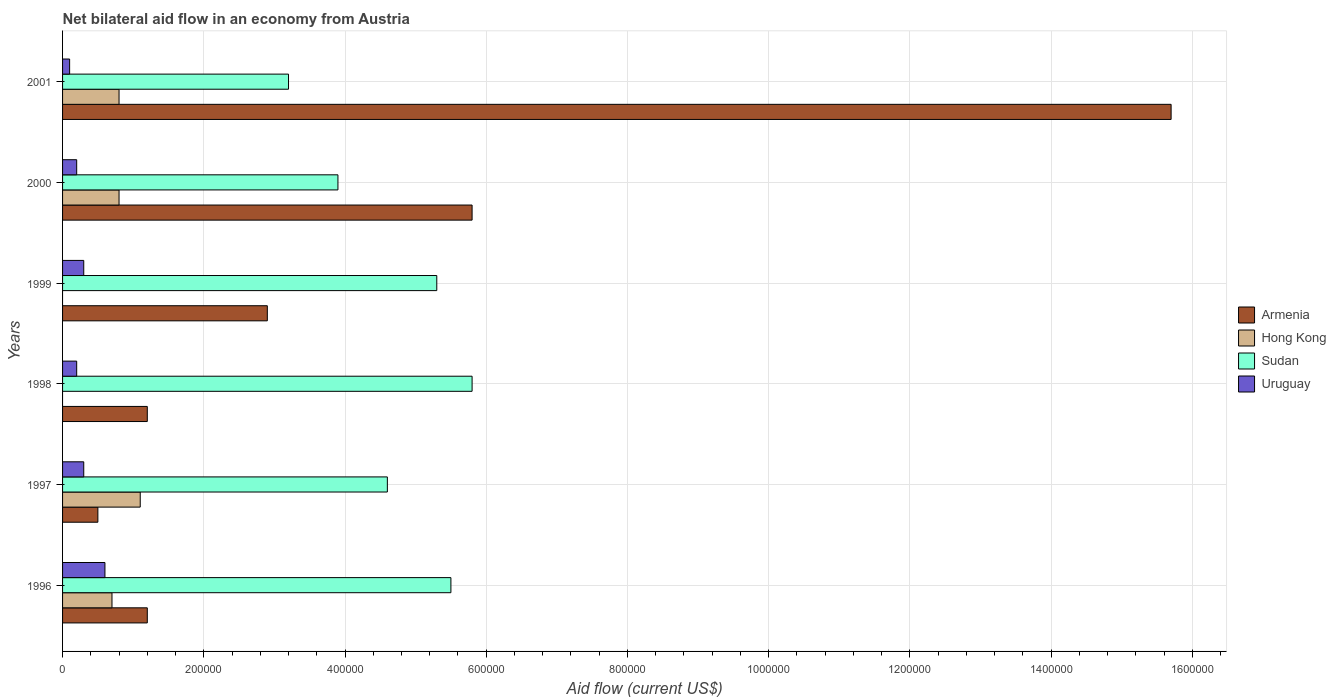How many different coloured bars are there?
Keep it short and to the point. 4. How many groups of bars are there?
Provide a succinct answer. 6. What is the net bilateral aid flow in Hong Kong in 1997?
Provide a short and direct response. 1.10e+05. Across all years, what is the maximum net bilateral aid flow in Sudan?
Provide a succinct answer. 5.80e+05. What is the total net bilateral aid flow in Armenia in the graph?
Give a very brief answer. 2.73e+06. What is the difference between the net bilateral aid flow in Hong Kong in 2001 and the net bilateral aid flow in Armenia in 1999?
Provide a succinct answer. -2.10e+05. What is the average net bilateral aid flow in Sudan per year?
Provide a short and direct response. 4.72e+05. In how many years, is the net bilateral aid flow in Sudan greater than 920000 US$?
Make the answer very short. 0. What is the ratio of the net bilateral aid flow in Sudan in 1999 to that in 2001?
Provide a succinct answer. 1.66. Is the difference between the net bilateral aid flow in Sudan in 1999 and 2001 greater than the difference between the net bilateral aid flow in Uruguay in 1999 and 2001?
Give a very brief answer. Yes. What is the difference between the highest and the lowest net bilateral aid flow in Armenia?
Your answer should be compact. 1.52e+06. In how many years, is the net bilateral aid flow in Sudan greater than the average net bilateral aid flow in Sudan taken over all years?
Give a very brief answer. 3. Is the sum of the net bilateral aid flow in Uruguay in 1996 and 1998 greater than the maximum net bilateral aid flow in Sudan across all years?
Offer a terse response. No. How many bars are there?
Provide a succinct answer. 22. Are all the bars in the graph horizontal?
Offer a very short reply. Yes. How many years are there in the graph?
Offer a very short reply. 6. What is the difference between two consecutive major ticks on the X-axis?
Offer a terse response. 2.00e+05. Are the values on the major ticks of X-axis written in scientific E-notation?
Provide a short and direct response. No. Does the graph contain any zero values?
Offer a terse response. Yes. How many legend labels are there?
Give a very brief answer. 4. What is the title of the graph?
Give a very brief answer. Net bilateral aid flow in an economy from Austria. Does "Brazil" appear as one of the legend labels in the graph?
Keep it short and to the point. No. What is the Aid flow (current US$) in Sudan in 1996?
Offer a terse response. 5.50e+05. What is the Aid flow (current US$) of Armenia in 1997?
Your response must be concise. 5.00e+04. What is the Aid flow (current US$) in Sudan in 1998?
Give a very brief answer. 5.80e+05. What is the Aid flow (current US$) in Sudan in 1999?
Give a very brief answer. 5.30e+05. What is the Aid flow (current US$) of Uruguay in 1999?
Ensure brevity in your answer.  3.00e+04. What is the Aid flow (current US$) of Armenia in 2000?
Offer a terse response. 5.80e+05. What is the Aid flow (current US$) of Armenia in 2001?
Provide a short and direct response. 1.57e+06. Across all years, what is the maximum Aid flow (current US$) of Armenia?
Your response must be concise. 1.57e+06. Across all years, what is the maximum Aid flow (current US$) in Hong Kong?
Provide a short and direct response. 1.10e+05. Across all years, what is the maximum Aid flow (current US$) of Sudan?
Make the answer very short. 5.80e+05. Across all years, what is the maximum Aid flow (current US$) in Uruguay?
Provide a succinct answer. 6.00e+04. Across all years, what is the minimum Aid flow (current US$) in Sudan?
Your response must be concise. 3.20e+05. What is the total Aid flow (current US$) of Armenia in the graph?
Give a very brief answer. 2.73e+06. What is the total Aid flow (current US$) of Sudan in the graph?
Give a very brief answer. 2.83e+06. What is the difference between the Aid flow (current US$) of Hong Kong in 1996 and that in 1997?
Provide a succinct answer. -4.00e+04. What is the difference between the Aid flow (current US$) in Uruguay in 1996 and that in 1998?
Your answer should be very brief. 4.00e+04. What is the difference between the Aid flow (current US$) in Armenia in 1996 and that in 1999?
Offer a terse response. -1.70e+05. What is the difference between the Aid flow (current US$) in Armenia in 1996 and that in 2000?
Provide a succinct answer. -4.60e+05. What is the difference between the Aid flow (current US$) in Uruguay in 1996 and that in 2000?
Provide a short and direct response. 4.00e+04. What is the difference between the Aid flow (current US$) of Armenia in 1996 and that in 2001?
Offer a very short reply. -1.45e+06. What is the difference between the Aid flow (current US$) of Sudan in 1996 and that in 2001?
Your response must be concise. 2.30e+05. What is the difference between the Aid flow (current US$) of Uruguay in 1996 and that in 2001?
Your response must be concise. 5.00e+04. What is the difference between the Aid flow (current US$) in Armenia in 1997 and that in 1998?
Offer a very short reply. -7.00e+04. What is the difference between the Aid flow (current US$) in Sudan in 1997 and that in 1998?
Provide a succinct answer. -1.20e+05. What is the difference between the Aid flow (current US$) in Sudan in 1997 and that in 1999?
Your response must be concise. -7.00e+04. What is the difference between the Aid flow (current US$) of Uruguay in 1997 and that in 1999?
Provide a short and direct response. 0. What is the difference between the Aid flow (current US$) in Armenia in 1997 and that in 2000?
Your answer should be very brief. -5.30e+05. What is the difference between the Aid flow (current US$) of Uruguay in 1997 and that in 2000?
Offer a terse response. 10000. What is the difference between the Aid flow (current US$) in Armenia in 1997 and that in 2001?
Give a very brief answer. -1.52e+06. What is the difference between the Aid flow (current US$) of Hong Kong in 1997 and that in 2001?
Your response must be concise. 3.00e+04. What is the difference between the Aid flow (current US$) in Armenia in 1998 and that in 1999?
Your response must be concise. -1.70e+05. What is the difference between the Aid flow (current US$) in Uruguay in 1998 and that in 1999?
Your response must be concise. -10000. What is the difference between the Aid flow (current US$) of Armenia in 1998 and that in 2000?
Offer a terse response. -4.60e+05. What is the difference between the Aid flow (current US$) of Sudan in 1998 and that in 2000?
Offer a terse response. 1.90e+05. What is the difference between the Aid flow (current US$) in Armenia in 1998 and that in 2001?
Keep it short and to the point. -1.45e+06. What is the difference between the Aid flow (current US$) in Uruguay in 1998 and that in 2001?
Provide a succinct answer. 10000. What is the difference between the Aid flow (current US$) of Sudan in 1999 and that in 2000?
Provide a short and direct response. 1.40e+05. What is the difference between the Aid flow (current US$) in Armenia in 1999 and that in 2001?
Provide a short and direct response. -1.28e+06. What is the difference between the Aid flow (current US$) in Uruguay in 1999 and that in 2001?
Offer a terse response. 2.00e+04. What is the difference between the Aid flow (current US$) in Armenia in 2000 and that in 2001?
Your answer should be very brief. -9.90e+05. What is the difference between the Aid flow (current US$) in Hong Kong in 2000 and that in 2001?
Provide a short and direct response. 0. What is the difference between the Aid flow (current US$) in Sudan in 2000 and that in 2001?
Your response must be concise. 7.00e+04. What is the difference between the Aid flow (current US$) in Uruguay in 2000 and that in 2001?
Give a very brief answer. 10000. What is the difference between the Aid flow (current US$) of Armenia in 1996 and the Aid flow (current US$) of Hong Kong in 1997?
Keep it short and to the point. 10000. What is the difference between the Aid flow (current US$) in Hong Kong in 1996 and the Aid flow (current US$) in Sudan in 1997?
Your answer should be very brief. -3.90e+05. What is the difference between the Aid flow (current US$) of Sudan in 1996 and the Aid flow (current US$) of Uruguay in 1997?
Your answer should be compact. 5.20e+05. What is the difference between the Aid flow (current US$) in Armenia in 1996 and the Aid flow (current US$) in Sudan in 1998?
Your answer should be very brief. -4.60e+05. What is the difference between the Aid flow (current US$) in Hong Kong in 1996 and the Aid flow (current US$) in Sudan in 1998?
Make the answer very short. -5.10e+05. What is the difference between the Aid flow (current US$) in Sudan in 1996 and the Aid flow (current US$) in Uruguay in 1998?
Ensure brevity in your answer.  5.30e+05. What is the difference between the Aid flow (current US$) in Armenia in 1996 and the Aid flow (current US$) in Sudan in 1999?
Keep it short and to the point. -4.10e+05. What is the difference between the Aid flow (current US$) in Hong Kong in 1996 and the Aid flow (current US$) in Sudan in 1999?
Your response must be concise. -4.60e+05. What is the difference between the Aid flow (current US$) of Sudan in 1996 and the Aid flow (current US$) of Uruguay in 1999?
Give a very brief answer. 5.20e+05. What is the difference between the Aid flow (current US$) of Armenia in 1996 and the Aid flow (current US$) of Sudan in 2000?
Your answer should be compact. -2.70e+05. What is the difference between the Aid flow (current US$) of Hong Kong in 1996 and the Aid flow (current US$) of Sudan in 2000?
Make the answer very short. -3.20e+05. What is the difference between the Aid flow (current US$) of Sudan in 1996 and the Aid flow (current US$) of Uruguay in 2000?
Give a very brief answer. 5.30e+05. What is the difference between the Aid flow (current US$) of Armenia in 1996 and the Aid flow (current US$) of Hong Kong in 2001?
Give a very brief answer. 4.00e+04. What is the difference between the Aid flow (current US$) of Armenia in 1996 and the Aid flow (current US$) of Sudan in 2001?
Ensure brevity in your answer.  -2.00e+05. What is the difference between the Aid flow (current US$) in Armenia in 1996 and the Aid flow (current US$) in Uruguay in 2001?
Provide a short and direct response. 1.10e+05. What is the difference between the Aid flow (current US$) of Hong Kong in 1996 and the Aid flow (current US$) of Sudan in 2001?
Give a very brief answer. -2.50e+05. What is the difference between the Aid flow (current US$) of Sudan in 1996 and the Aid flow (current US$) of Uruguay in 2001?
Your response must be concise. 5.40e+05. What is the difference between the Aid flow (current US$) of Armenia in 1997 and the Aid flow (current US$) of Sudan in 1998?
Ensure brevity in your answer.  -5.30e+05. What is the difference between the Aid flow (current US$) in Hong Kong in 1997 and the Aid flow (current US$) in Sudan in 1998?
Your answer should be very brief. -4.70e+05. What is the difference between the Aid flow (current US$) in Hong Kong in 1997 and the Aid flow (current US$) in Uruguay in 1998?
Offer a terse response. 9.00e+04. What is the difference between the Aid flow (current US$) in Sudan in 1997 and the Aid flow (current US$) in Uruguay in 1998?
Provide a short and direct response. 4.40e+05. What is the difference between the Aid flow (current US$) of Armenia in 1997 and the Aid flow (current US$) of Sudan in 1999?
Keep it short and to the point. -4.80e+05. What is the difference between the Aid flow (current US$) in Armenia in 1997 and the Aid flow (current US$) in Uruguay in 1999?
Your response must be concise. 2.00e+04. What is the difference between the Aid flow (current US$) in Hong Kong in 1997 and the Aid flow (current US$) in Sudan in 1999?
Offer a terse response. -4.20e+05. What is the difference between the Aid flow (current US$) of Armenia in 1997 and the Aid flow (current US$) of Hong Kong in 2000?
Your answer should be compact. -3.00e+04. What is the difference between the Aid flow (current US$) of Hong Kong in 1997 and the Aid flow (current US$) of Sudan in 2000?
Keep it short and to the point. -2.80e+05. What is the difference between the Aid flow (current US$) of Hong Kong in 1997 and the Aid flow (current US$) of Uruguay in 2000?
Give a very brief answer. 9.00e+04. What is the difference between the Aid flow (current US$) of Sudan in 1997 and the Aid flow (current US$) of Uruguay in 2000?
Make the answer very short. 4.40e+05. What is the difference between the Aid flow (current US$) in Armenia in 1997 and the Aid flow (current US$) in Sudan in 2001?
Give a very brief answer. -2.70e+05. What is the difference between the Aid flow (current US$) of Armenia in 1997 and the Aid flow (current US$) of Uruguay in 2001?
Provide a short and direct response. 4.00e+04. What is the difference between the Aid flow (current US$) in Hong Kong in 1997 and the Aid flow (current US$) in Sudan in 2001?
Provide a succinct answer. -2.10e+05. What is the difference between the Aid flow (current US$) of Hong Kong in 1997 and the Aid flow (current US$) of Uruguay in 2001?
Keep it short and to the point. 1.00e+05. What is the difference between the Aid flow (current US$) in Sudan in 1997 and the Aid flow (current US$) in Uruguay in 2001?
Ensure brevity in your answer.  4.50e+05. What is the difference between the Aid flow (current US$) of Armenia in 1998 and the Aid flow (current US$) of Sudan in 1999?
Keep it short and to the point. -4.10e+05. What is the difference between the Aid flow (current US$) of Sudan in 1998 and the Aid flow (current US$) of Uruguay in 1999?
Make the answer very short. 5.50e+05. What is the difference between the Aid flow (current US$) in Armenia in 1998 and the Aid flow (current US$) in Hong Kong in 2000?
Provide a succinct answer. 4.00e+04. What is the difference between the Aid flow (current US$) of Armenia in 1998 and the Aid flow (current US$) of Uruguay in 2000?
Provide a short and direct response. 1.00e+05. What is the difference between the Aid flow (current US$) in Sudan in 1998 and the Aid flow (current US$) in Uruguay in 2000?
Offer a very short reply. 5.60e+05. What is the difference between the Aid flow (current US$) of Armenia in 1998 and the Aid flow (current US$) of Sudan in 2001?
Provide a short and direct response. -2.00e+05. What is the difference between the Aid flow (current US$) of Armenia in 1998 and the Aid flow (current US$) of Uruguay in 2001?
Your response must be concise. 1.10e+05. What is the difference between the Aid flow (current US$) of Sudan in 1998 and the Aid flow (current US$) of Uruguay in 2001?
Offer a very short reply. 5.70e+05. What is the difference between the Aid flow (current US$) of Armenia in 1999 and the Aid flow (current US$) of Hong Kong in 2000?
Provide a succinct answer. 2.10e+05. What is the difference between the Aid flow (current US$) of Sudan in 1999 and the Aid flow (current US$) of Uruguay in 2000?
Ensure brevity in your answer.  5.10e+05. What is the difference between the Aid flow (current US$) of Armenia in 1999 and the Aid flow (current US$) of Hong Kong in 2001?
Keep it short and to the point. 2.10e+05. What is the difference between the Aid flow (current US$) of Armenia in 1999 and the Aid flow (current US$) of Sudan in 2001?
Make the answer very short. -3.00e+04. What is the difference between the Aid flow (current US$) of Sudan in 1999 and the Aid flow (current US$) of Uruguay in 2001?
Your response must be concise. 5.20e+05. What is the difference between the Aid flow (current US$) in Armenia in 2000 and the Aid flow (current US$) in Uruguay in 2001?
Provide a short and direct response. 5.70e+05. What is the difference between the Aid flow (current US$) in Hong Kong in 2000 and the Aid flow (current US$) in Sudan in 2001?
Make the answer very short. -2.40e+05. What is the difference between the Aid flow (current US$) of Sudan in 2000 and the Aid flow (current US$) of Uruguay in 2001?
Provide a succinct answer. 3.80e+05. What is the average Aid flow (current US$) in Armenia per year?
Offer a very short reply. 4.55e+05. What is the average Aid flow (current US$) in Hong Kong per year?
Keep it short and to the point. 5.67e+04. What is the average Aid flow (current US$) in Sudan per year?
Keep it short and to the point. 4.72e+05. What is the average Aid flow (current US$) in Uruguay per year?
Your answer should be compact. 2.83e+04. In the year 1996, what is the difference between the Aid flow (current US$) of Armenia and Aid flow (current US$) of Hong Kong?
Your answer should be very brief. 5.00e+04. In the year 1996, what is the difference between the Aid flow (current US$) in Armenia and Aid flow (current US$) in Sudan?
Provide a succinct answer. -4.30e+05. In the year 1996, what is the difference between the Aid flow (current US$) of Armenia and Aid flow (current US$) of Uruguay?
Offer a terse response. 6.00e+04. In the year 1996, what is the difference between the Aid flow (current US$) in Hong Kong and Aid flow (current US$) in Sudan?
Ensure brevity in your answer.  -4.80e+05. In the year 1996, what is the difference between the Aid flow (current US$) in Hong Kong and Aid flow (current US$) in Uruguay?
Offer a terse response. 10000. In the year 1997, what is the difference between the Aid flow (current US$) of Armenia and Aid flow (current US$) of Sudan?
Make the answer very short. -4.10e+05. In the year 1997, what is the difference between the Aid flow (current US$) of Hong Kong and Aid flow (current US$) of Sudan?
Give a very brief answer. -3.50e+05. In the year 1998, what is the difference between the Aid flow (current US$) in Armenia and Aid flow (current US$) in Sudan?
Your answer should be very brief. -4.60e+05. In the year 1998, what is the difference between the Aid flow (current US$) in Armenia and Aid flow (current US$) in Uruguay?
Provide a succinct answer. 1.00e+05. In the year 1998, what is the difference between the Aid flow (current US$) of Sudan and Aid flow (current US$) of Uruguay?
Offer a terse response. 5.60e+05. In the year 1999, what is the difference between the Aid flow (current US$) of Armenia and Aid flow (current US$) of Uruguay?
Your answer should be very brief. 2.60e+05. In the year 2000, what is the difference between the Aid flow (current US$) of Armenia and Aid flow (current US$) of Hong Kong?
Your answer should be very brief. 5.00e+05. In the year 2000, what is the difference between the Aid flow (current US$) in Armenia and Aid flow (current US$) in Uruguay?
Give a very brief answer. 5.60e+05. In the year 2000, what is the difference between the Aid flow (current US$) of Hong Kong and Aid flow (current US$) of Sudan?
Give a very brief answer. -3.10e+05. In the year 2000, what is the difference between the Aid flow (current US$) of Hong Kong and Aid flow (current US$) of Uruguay?
Your answer should be very brief. 6.00e+04. In the year 2001, what is the difference between the Aid flow (current US$) of Armenia and Aid flow (current US$) of Hong Kong?
Keep it short and to the point. 1.49e+06. In the year 2001, what is the difference between the Aid flow (current US$) in Armenia and Aid flow (current US$) in Sudan?
Your answer should be very brief. 1.25e+06. In the year 2001, what is the difference between the Aid flow (current US$) of Armenia and Aid flow (current US$) of Uruguay?
Provide a succinct answer. 1.56e+06. In the year 2001, what is the difference between the Aid flow (current US$) of Sudan and Aid flow (current US$) of Uruguay?
Your answer should be very brief. 3.10e+05. What is the ratio of the Aid flow (current US$) of Armenia in 1996 to that in 1997?
Keep it short and to the point. 2.4. What is the ratio of the Aid flow (current US$) in Hong Kong in 1996 to that in 1997?
Keep it short and to the point. 0.64. What is the ratio of the Aid flow (current US$) of Sudan in 1996 to that in 1997?
Ensure brevity in your answer.  1.2. What is the ratio of the Aid flow (current US$) of Sudan in 1996 to that in 1998?
Give a very brief answer. 0.95. What is the ratio of the Aid flow (current US$) of Uruguay in 1996 to that in 1998?
Provide a short and direct response. 3. What is the ratio of the Aid flow (current US$) of Armenia in 1996 to that in 1999?
Provide a succinct answer. 0.41. What is the ratio of the Aid flow (current US$) of Sudan in 1996 to that in 1999?
Give a very brief answer. 1.04. What is the ratio of the Aid flow (current US$) in Uruguay in 1996 to that in 1999?
Provide a succinct answer. 2. What is the ratio of the Aid flow (current US$) in Armenia in 1996 to that in 2000?
Offer a very short reply. 0.21. What is the ratio of the Aid flow (current US$) of Sudan in 1996 to that in 2000?
Provide a short and direct response. 1.41. What is the ratio of the Aid flow (current US$) of Armenia in 1996 to that in 2001?
Offer a very short reply. 0.08. What is the ratio of the Aid flow (current US$) of Hong Kong in 1996 to that in 2001?
Make the answer very short. 0.88. What is the ratio of the Aid flow (current US$) of Sudan in 1996 to that in 2001?
Keep it short and to the point. 1.72. What is the ratio of the Aid flow (current US$) of Uruguay in 1996 to that in 2001?
Offer a terse response. 6. What is the ratio of the Aid flow (current US$) of Armenia in 1997 to that in 1998?
Make the answer very short. 0.42. What is the ratio of the Aid flow (current US$) in Sudan in 1997 to that in 1998?
Offer a terse response. 0.79. What is the ratio of the Aid flow (current US$) of Uruguay in 1997 to that in 1998?
Your answer should be very brief. 1.5. What is the ratio of the Aid flow (current US$) in Armenia in 1997 to that in 1999?
Provide a succinct answer. 0.17. What is the ratio of the Aid flow (current US$) of Sudan in 1997 to that in 1999?
Your answer should be very brief. 0.87. What is the ratio of the Aid flow (current US$) in Armenia in 1997 to that in 2000?
Ensure brevity in your answer.  0.09. What is the ratio of the Aid flow (current US$) in Hong Kong in 1997 to that in 2000?
Provide a succinct answer. 1.38. What is the ratio of the Aid flow (current US$) of Sudan in 1997 to that in 2000?
Offer a very short reply. 1.18. What is the ratio of the Aid flow (current US$) in Armenia in 1997 to that in 2001?
Your answer should be very brief. 0.03. What is the ratio of the Aid flow (current US$) in Hong Kong in 1997 to that in 2001?
Keep it short and to the point. 1.38. What is the ratio of the Aid flow (current US$) in Sudan in 1997 to that in 2001?
Offer a very short reply. 1.44. What is the ratio of the Aid flow (current US$) in Armenia in 1998 to that in 1999?
Ensure brevity in your answer.  0.41. What is the ratio of the Aid flow (current US$) in Sudan in 1998 to that in 1999?
Make the answer very short. 1.09. What is the ratio of the Aid flow (current US$) in Uruguay in 1998 to that in 1999?
Give a very brief answer. 0.67. What is the ratio of the Aid flow (current US$) of Armenia in 1998 to that in 2000?
Ensure brevity in your answer.  0.21. What is the ratio of the Aid flow (current US$) in Sudan in 1998 to that in 2000?
Your answer should be compact. 1.49. What is the ratio of the Aid flow (current US$) of Uruguay in 1998 to that in 2000?
Your answer should be very brief. 1. What is the ratio of the Aid flow (current US$) in Armenia in 1998 to that in 2001?
Give a very brief answer. 0.08. What is the ratio of the Aid flow (current US$) of Sudan in 1998 to that in 2001?
Give a very brief answer. 1.81. What is the ratio of the Aid flow (current US$) of Uruguay in 1998 to that in 2001?
Your answer should be compact. 2. What is the ratio of the Aid flow (current US$) in Sudan in 1999 to that in 2000?
Give a very brief answer. 1.36. What is the ratio of the Aid flow (current US$) in Armenia in 1999 to that in 2001?
Make the answer very short. 0.18. What is the ratio of the Aid flow (current US$) of Sudan in 1999 to that in 2001?
Your answer should be very brief. 1.66. What is the ratio of the Aid flow (current US$) in Uruguay in 1999 to that in 2001?
Your answer should be compact. 3. What is the ratio of the Aid flow (current US$) of Armenia in 2000 to that in 2001?
Give a very brief answer. 0.37. What is the ratio of the Aid flow (current US$) in Sudan in 2000 to that in 2001?
Provide a short and direct response. 1.22. What is the difference between the highest and the second highest Aid flow (current US$) in Armenia?
Make the answer very short. 9.90e+05. What is the difference between the highest and the second highest Aid flow (current US$) of Hong Kong?
Provide a succinct answer. 3.00e+04. What is the difference between the highest and the second highest Aid flow (current US$) of Sudan?
Your answer should be very brief. 3.00e+04. What is the difference between the highest and the lowest Aid flow (current US$) of Armenia?
Ensure brevity in your answer.  1.52e+06. What is the difference between the highest and the lowest Aid flow (current US$) in Hong Kong?
Keep it short and to the point. 1.10e+05. What is the difference between the highest and the lowest Aid flow (current US$) of Sudan?
Make the answer very short. 2.60e+05. What is the difference between the highest and the lowest Aid flow (current US$) of Uruguay?
Ensure brevity in your answer.  5.00e+04. 